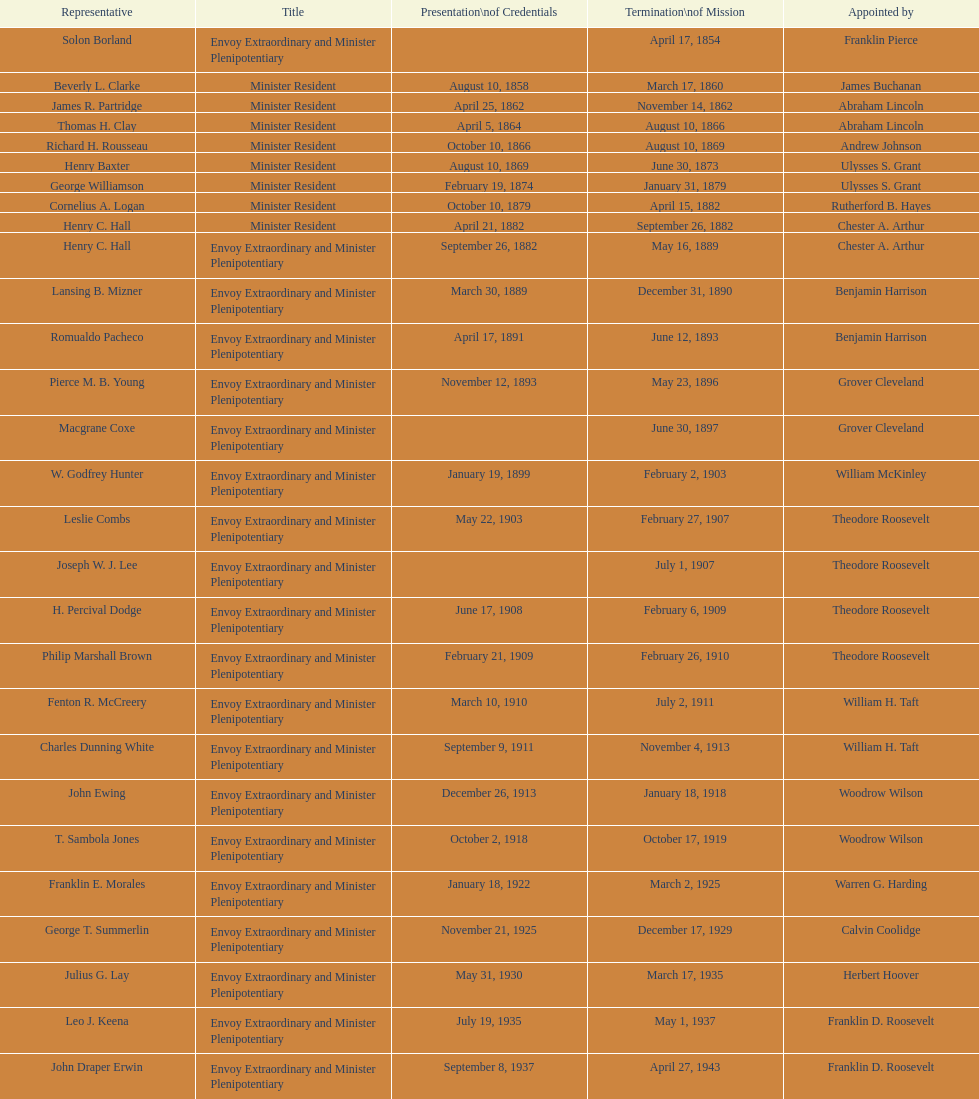What was the length, in years, of leslie combs' term? 4 years. 